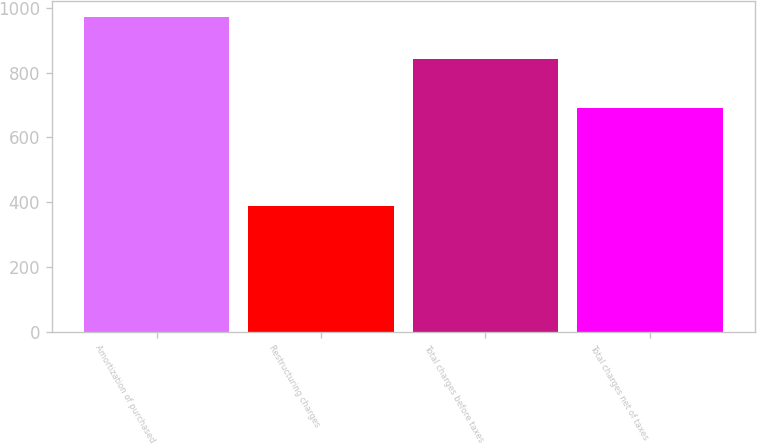Convert chart. <chart><loc_0><loc_0><loc_500><loc_500><bar_chart><fcel>Amortization of purchased<fcel>Restructuring charges<fcel>Total charges before taxes<fcel>Total charges net of taxes<nl><fcel>973<fcel>387<fcel>843<fcel>690<nl></chart> 